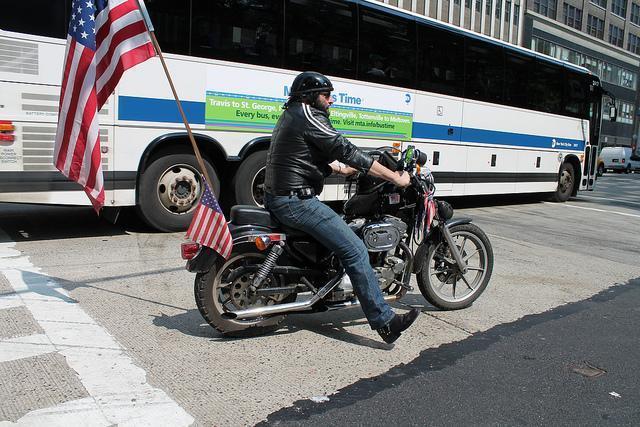How many people can you see?
Give a very brief answer. 1. 